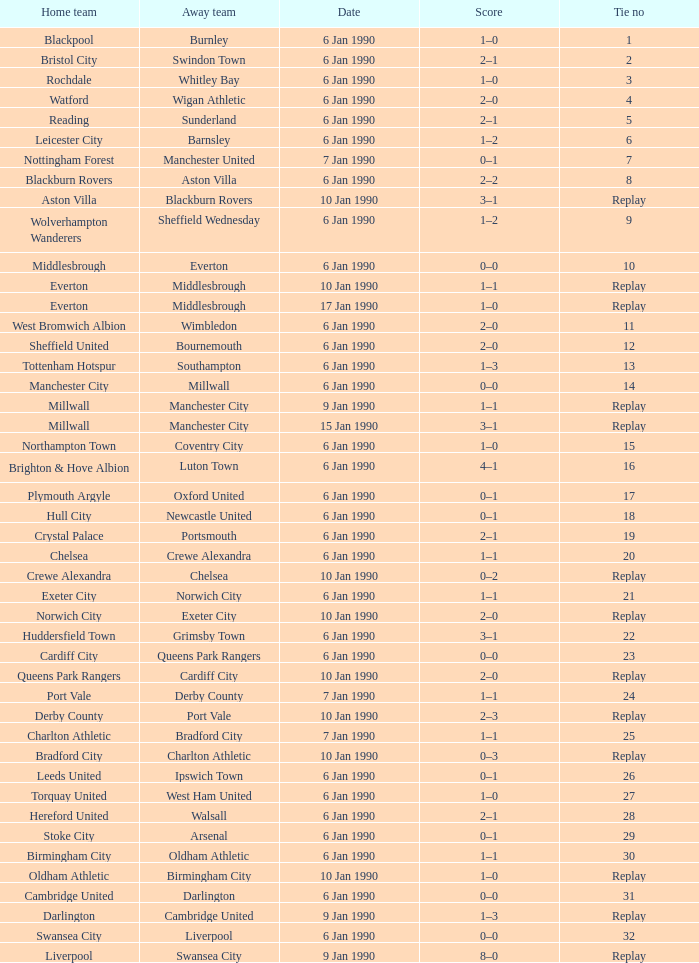What date did home team liverpool play? 9 Jan 1990. 